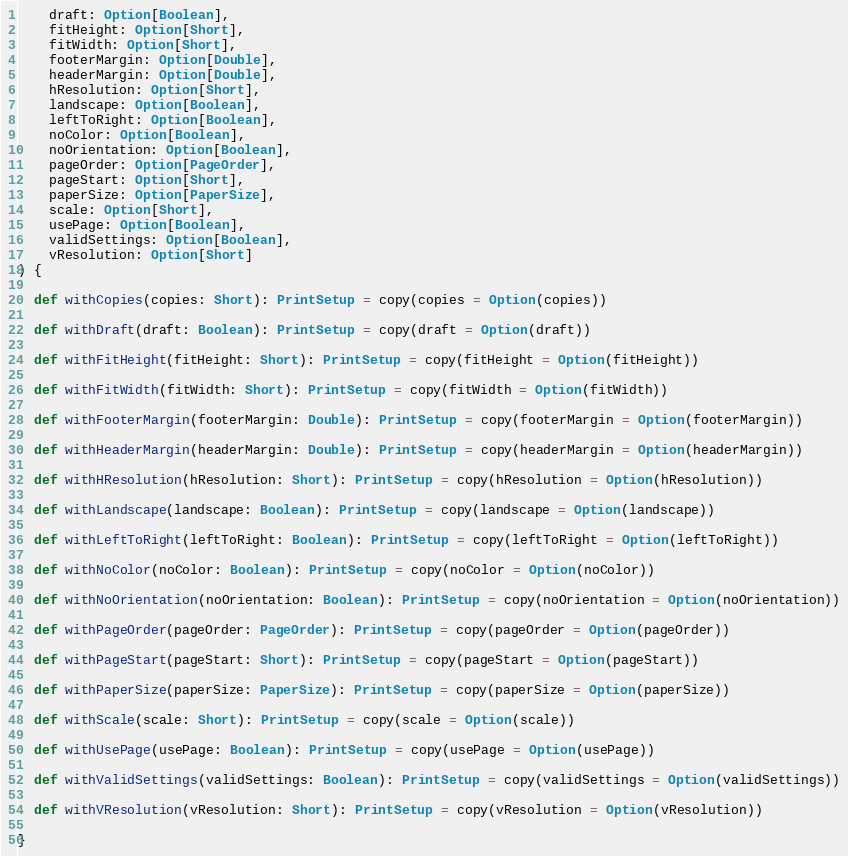<code> <loc_0><loc_0><loc_500><loc_500><_Scala_>    draft: Option[Boolean],
    fitHeight: Option[Short],
    fitWidth: Option[Short],
    footerMargin: Option[Double],
    headerMargin: Option[Double],
    hResolution: Option[Short],
    landscape: Option[Boolean],
    leftToRight: Option[Boolean],
    noColor: Option[Boolean],
    noOrientation: Option[Boolean],
    pageOrder: Option[PageOrder],
    pageStart: Option[Short],
    paperSize: Option[PaperSize],
    scale: Option[Short],
    usePage: Option[Boolean],
    validSettings: Option[Boolean],
    vResolution: Option[Short]
) {

  def withCopies(copies: Short): PrintSetup = copy(copies = Option(copies))

  def withDraft(draft: Boolean): PrintSetup = copy(draft = Option(draft))

  def withFitHeight(fitHeight: Short): PrintSetup = copy(fitHeight = Option(fitHeight))

  def withFitWidth(fitWidth: Short): PrintSetup = copy(fitWidth = Option(fitWidth))

  def withFooterMargin(footerMargin: Double): PrintSetup = copy(footerMargin = Option(footerMargin))

  def withHeaderMargin(headerMargin: Double): PrintSetup = copy(headerMargin = Option(headerMargin))

  def withHResolution(hResolution: Short): PrintSetup = copy(hResolution = Option(hResolution))

  def withLandscape(landscape: Boolean): PrintSetup = copy(landscape = Option(landscape))

  def withLeftToRight(leftToRight: Boolean): PrintSetup = copy(leftToRight = Option(leftToRight))

  def withNoColor(noColor: Boolean): PrintSetup = copy(noColor = Option(noColor))

  def withNoOrientation(noOrientation: Boolean): PrintSetup = copy(noOrientation = Option(noOrientation))

  def withPageOrder(pageOrder: PageOrder): PrintSetup = copy(pageOrder = Option(pageOrder))

  def withPageStart(pageStart: Short): PrintSetup = copy(pageStart = Option(pageStart))

  def withPaperSize(paperSize: PaperSize): PrintSetup = copy(paperSize = Option(paperSize))

  def withScale(scale: Short): PrintSetup = copy(scale = Option(scale))

  def withUsePage(usePage: Boolean): PrintSetup = copy(usePage = Option(usePage))

  def withValidSettings(validSettings: Boolean): PrintSetup = copy(validSettings = Option(validSettings))

  def withVResolution(vResolution: Short): PrintSetup = copy(vResolution = Option(vResolution))

}
</code> 